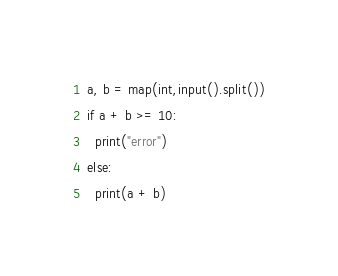Convert code to text. <code><loc_0><loc_0><loc_500><loc_500><_Python_>a, b = map(int,input().split())
if a + b >= 10:
  print("error")
else:
  print(a + b)</code> 